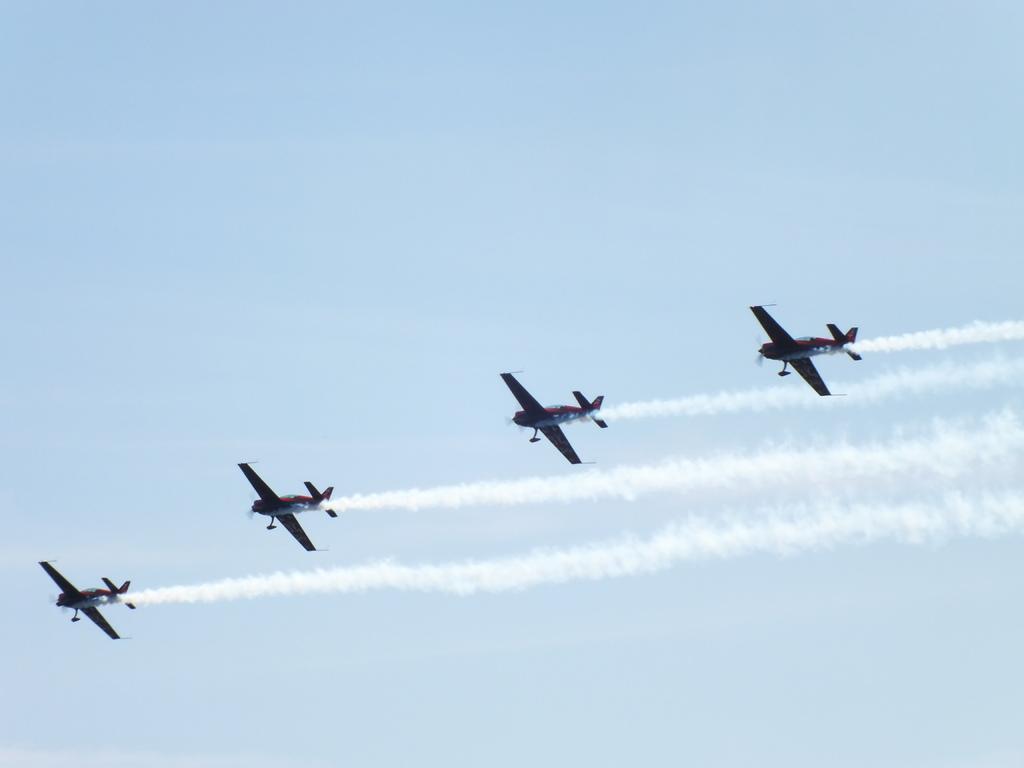Please provide a concise description of this image. In this picture I can observe four airplanes flying in the air. In the background there is a sky. 